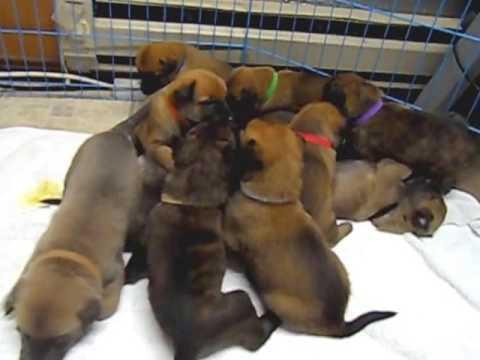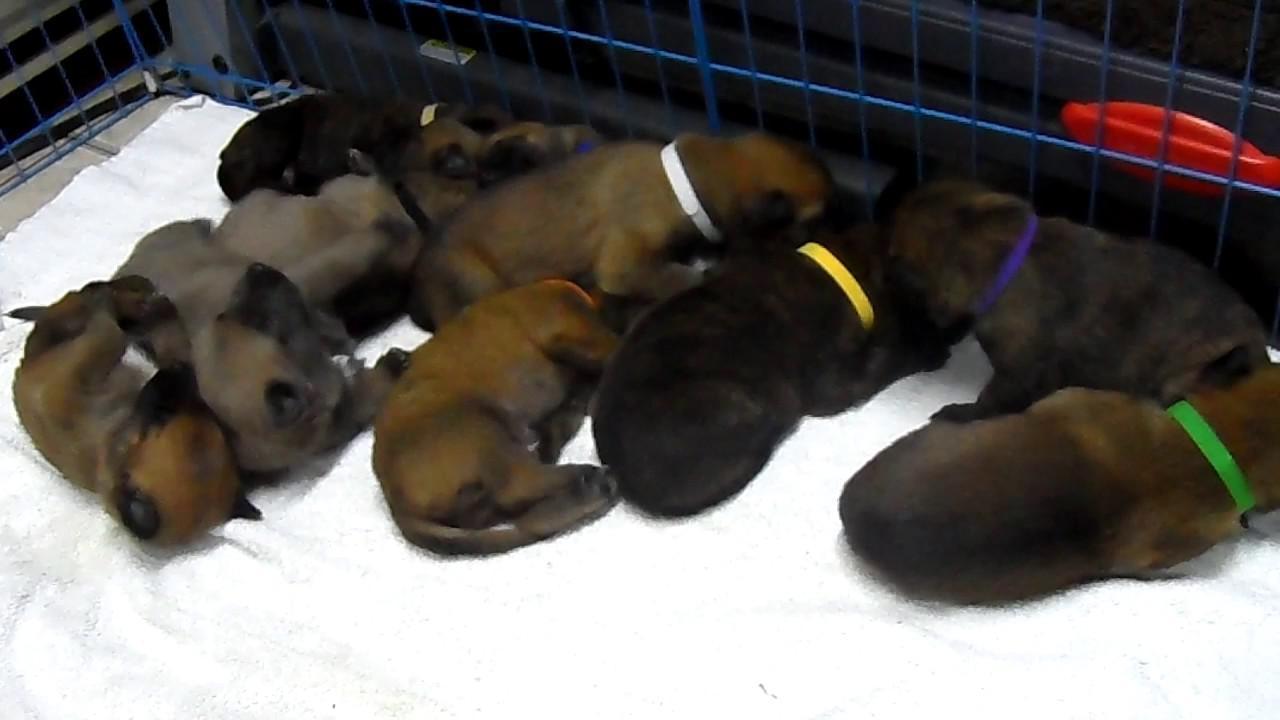The first image is the image on the left, the second image is the image on the right. Given the left and right images, does the statement "The puppies in at least one of the images are in a wired cage." hold true? Answer yes or no. Yes. The first image is the image on the left, the second image is the image on the right. For the images displayed, is the sentence "Each image shows a pile of puppies, and at least one pile of puppies is surrounded by a wire enclosure." factually correct? Answer yes or no. Yes. 